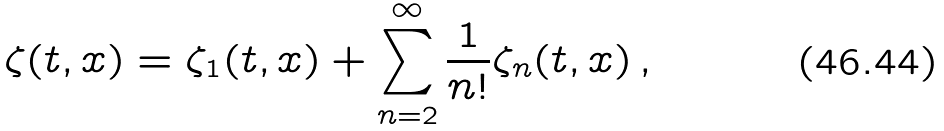Convert formula to latex. <formula><loc_0><loc_0><loc_500><loc_500>\zeta ( t , { x } ) = \zeta _ { 1 } ( t , { x } ) + \sum _ { n = 2 } ^ { \infty } \frac { 1 } { n ! } \zeta _ { n } ( t , { x } ) \, ,</formula> 